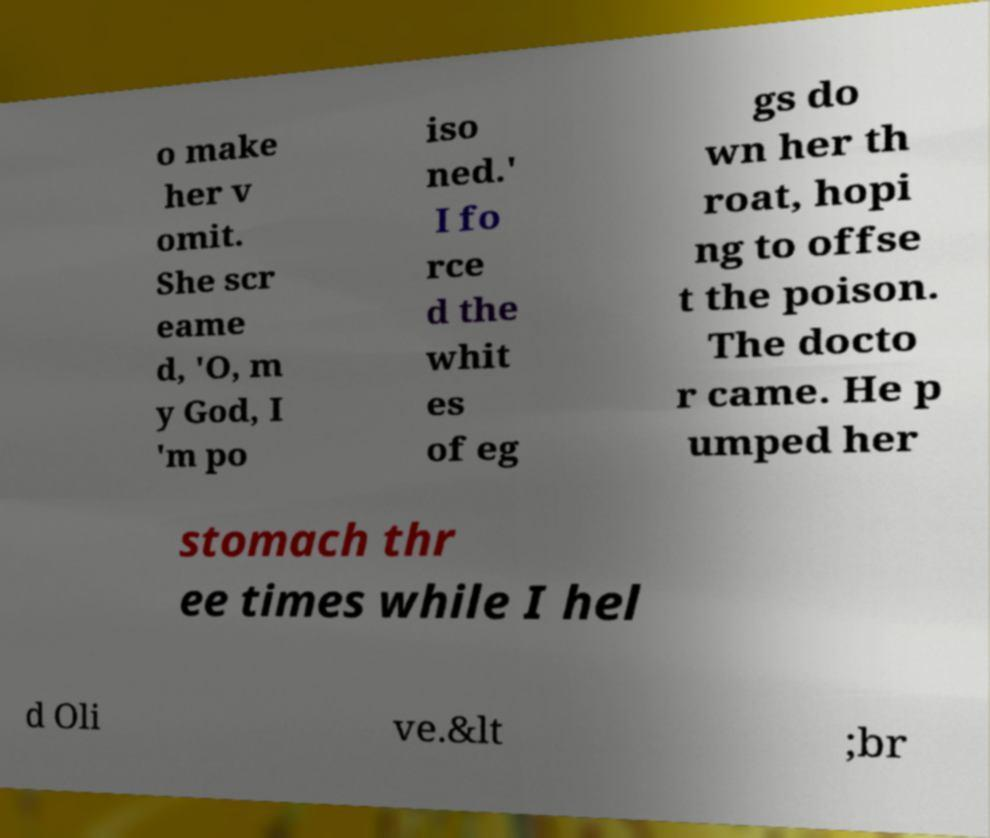Please read and relay the text visible in this image. What does it say? o make her v omit. She scr eame d, 'O, m y God, I 'm po iso ned.' I fo rce d the whit es of eg gs do wn her th roat, hopi ng to offse t the poison. The docto r came. He p umped her stomach thr ee times while I hel d Oli ve.&lt ;br 